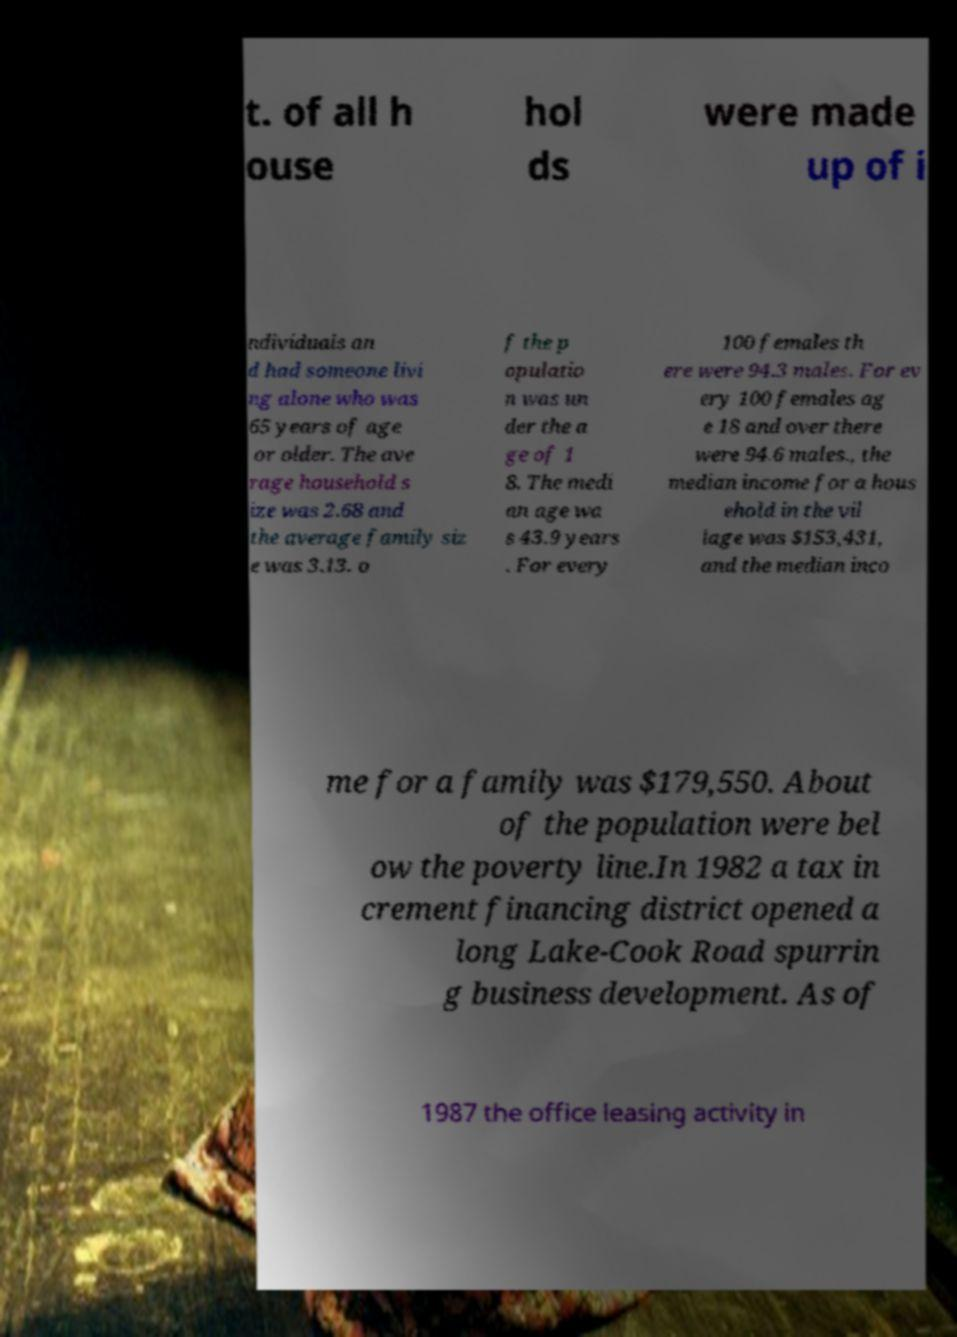Please read and relay the text visible in this image. What does it say? t. of all h ouse hol ds were made up of i ndividuals an d had someone livi ng alone who was 65 years of age or older. The ave rage household s ize was 2.68 and the average family siz e was 3.13. o f the p opulatio n was un der the a ge of 1 8. The medi an age wa s 43.9 years . For every 100 females th ere were 94.3 males. For ev ery 100 females ag e 18 and over there were 94.6 males., the median income for a hous ehold in the vil lage was $153,431, and the median inco me for a family was $179,550. About of the population were bel ow the poverty line.In 1982 a tax in crement financing district opened a long Lake-Cook Road spurrin g business development. As of 1987 the office leasing activity in 